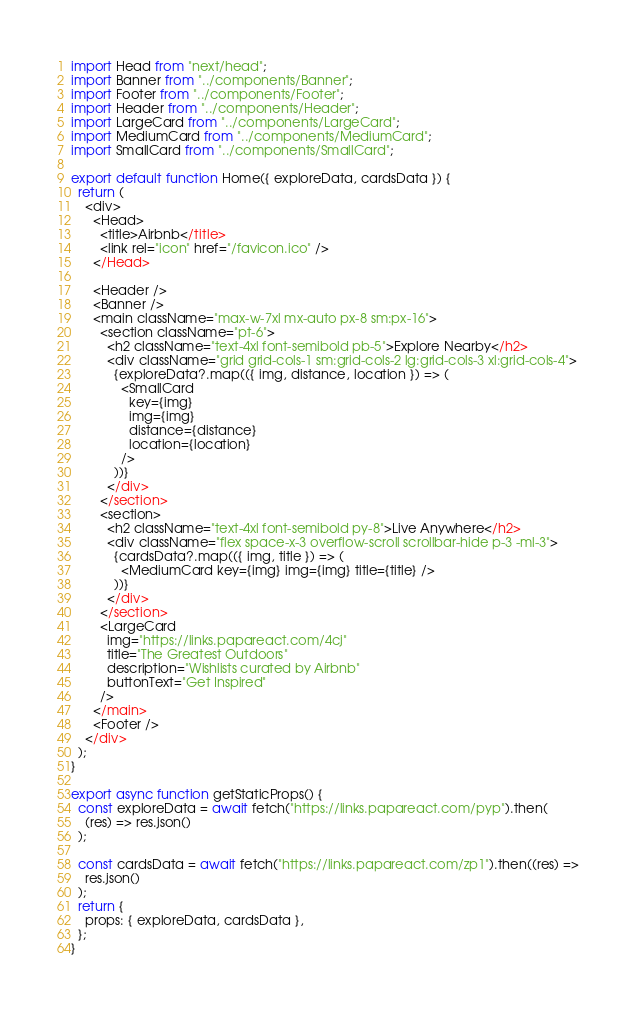<code> <loc_0><loc_0><loc_500><loc_500><_JavaScript_>import Head from "next/head";
import Banner from "../components/Banner";
import Footer from "../components/Footer";
import Header from "../components/Header";
import LargeCard from "../components/LargeCard";
import MediumCard from "../components/MediumCard";
import SmallCard from "../components/SmallCard";

export default function Home({ exploreData, cardsData }) {
  return (
    <div>
      <Head>
        <title>Airbnb</title>
        <link rel="icon" href="/favicon.ico" />
      </Head>

      <Header />
      <Banner />
      <main className="max-w-7xl mx-auto px-8 sm:px-16">
        <section className="pt-6">
          <h2 className="text-4xl font-semibold pb-5">Explore Nearby</h2>
          <div className="grid grid-cols-1 sm:grid-cols-2 lg:grid-cols-3 xl:grid-cols-4">
            {exploreData?.map(({ img, distance, location }) => (
              <SmallCard
                key={img}
                img={img}
                distance={distance}
                location={location}
              />
            ))}
          </div>
        </section>
        <section>
          <h2 className="text-4xl font-semibold py-8">Live Anywhere</h2>
          <div className="flex space-x-3 overflow-scroll scrollbar-hide p-3 -ml-3">
            {cardsData?.map(({ img, title }) => (
              <MediumCard key={img} img={img} title={title} />
            ))}
          </div>
        </section>
        <LargeCard
          img="https://links.papareact.com/4cj"
          title="The Greatest Outdoors"
          description="Wishlists curated by Airbnb"
          buttonText="Get Inspired"
        />
      </main>
      <Footer />
    </div>
  );
}

export async function getStaticProps() {
  const exploreData = await fetch("https://links.papareact.com/pyp").then(
    (res) => res.json()
  );

  const cardsData = await fetch("https://links.papareact.com/zp1").then((res) =>
    res.json()
  );
  return {
    props: { exploreData, cardsData },
  };
}
</code> 